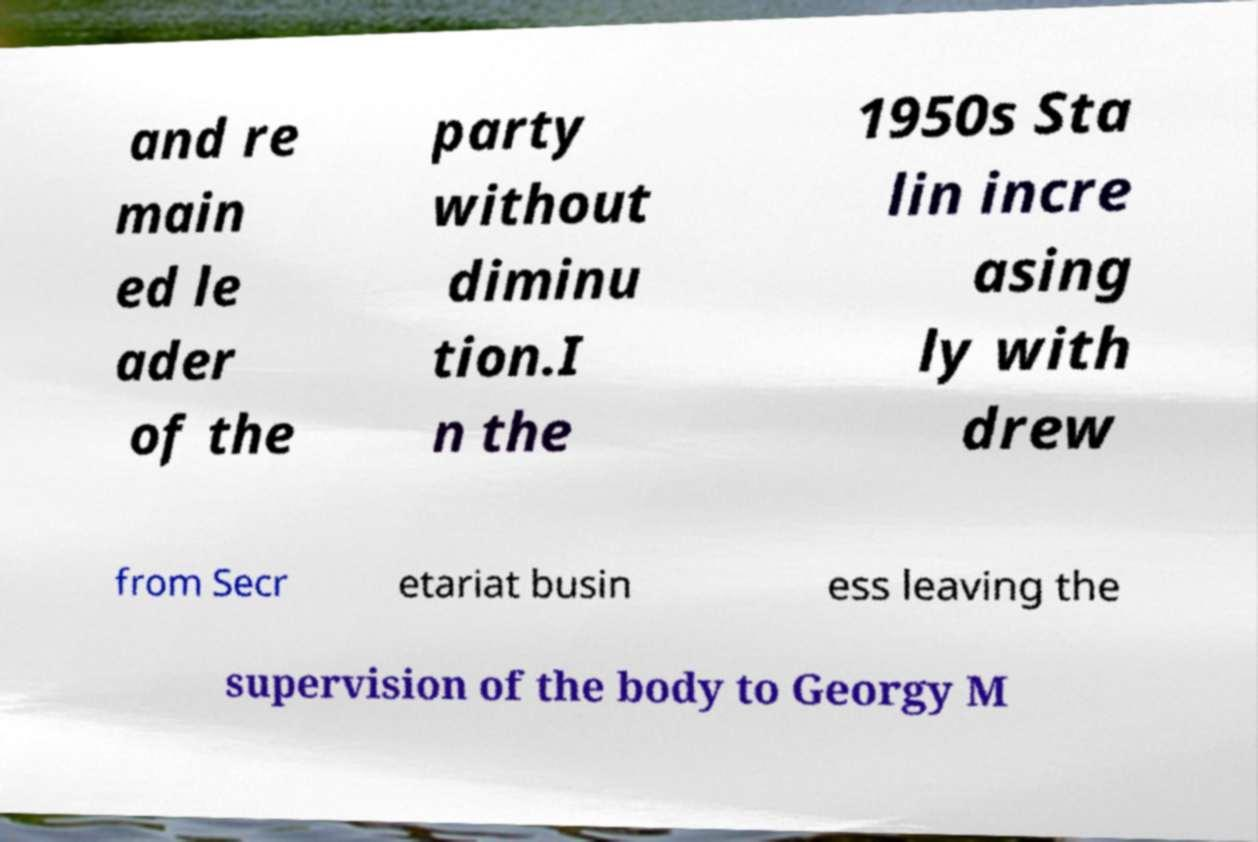What messages or text are displayed in this image? I need them in a readable, typed format. and re main ed le ader of the party without diminu tion.I n the 1950s Sta lin incre asing ly with drew from Secr etariat busin ess leaving the supervision of the body to Georgy M 